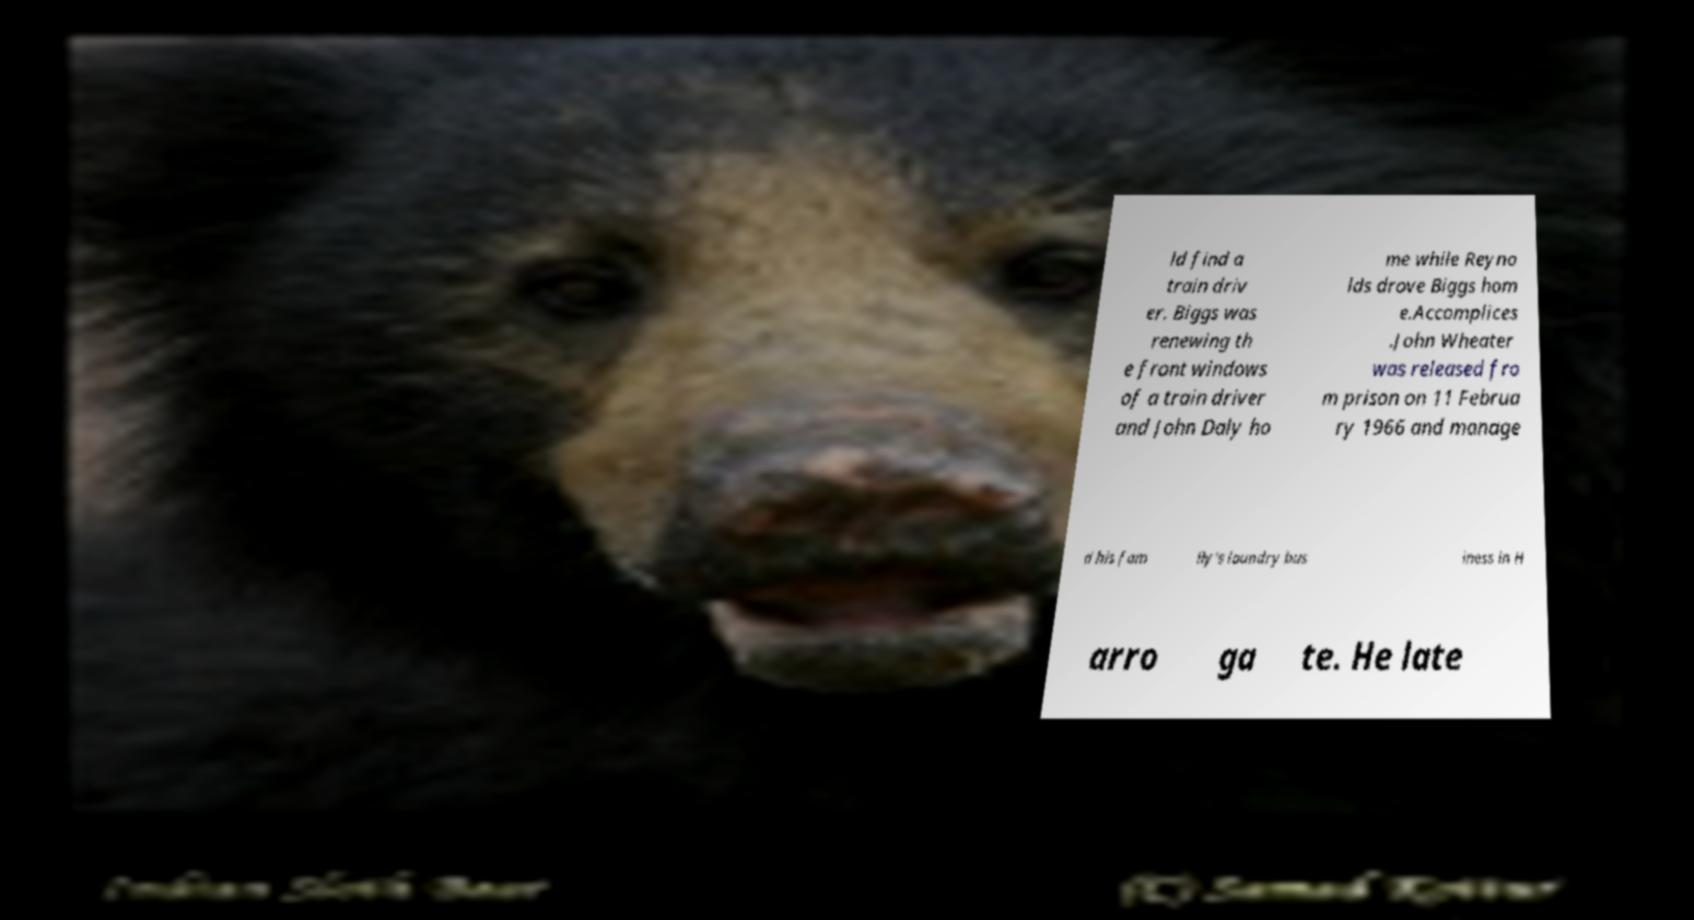There's text embedded in this image that I need extracted. Can you transcribe it verbatim? ld find a train driv er. Biggs was renewing th e front windows of a train driver and John Daly ho me while Reyno lds drove Biggs hom e.Accomplices .John Wheater was released fro m prison on 11 Februa ry 1966 and manage d his fam ily's laundry bus iness in H arro ga te. He late 